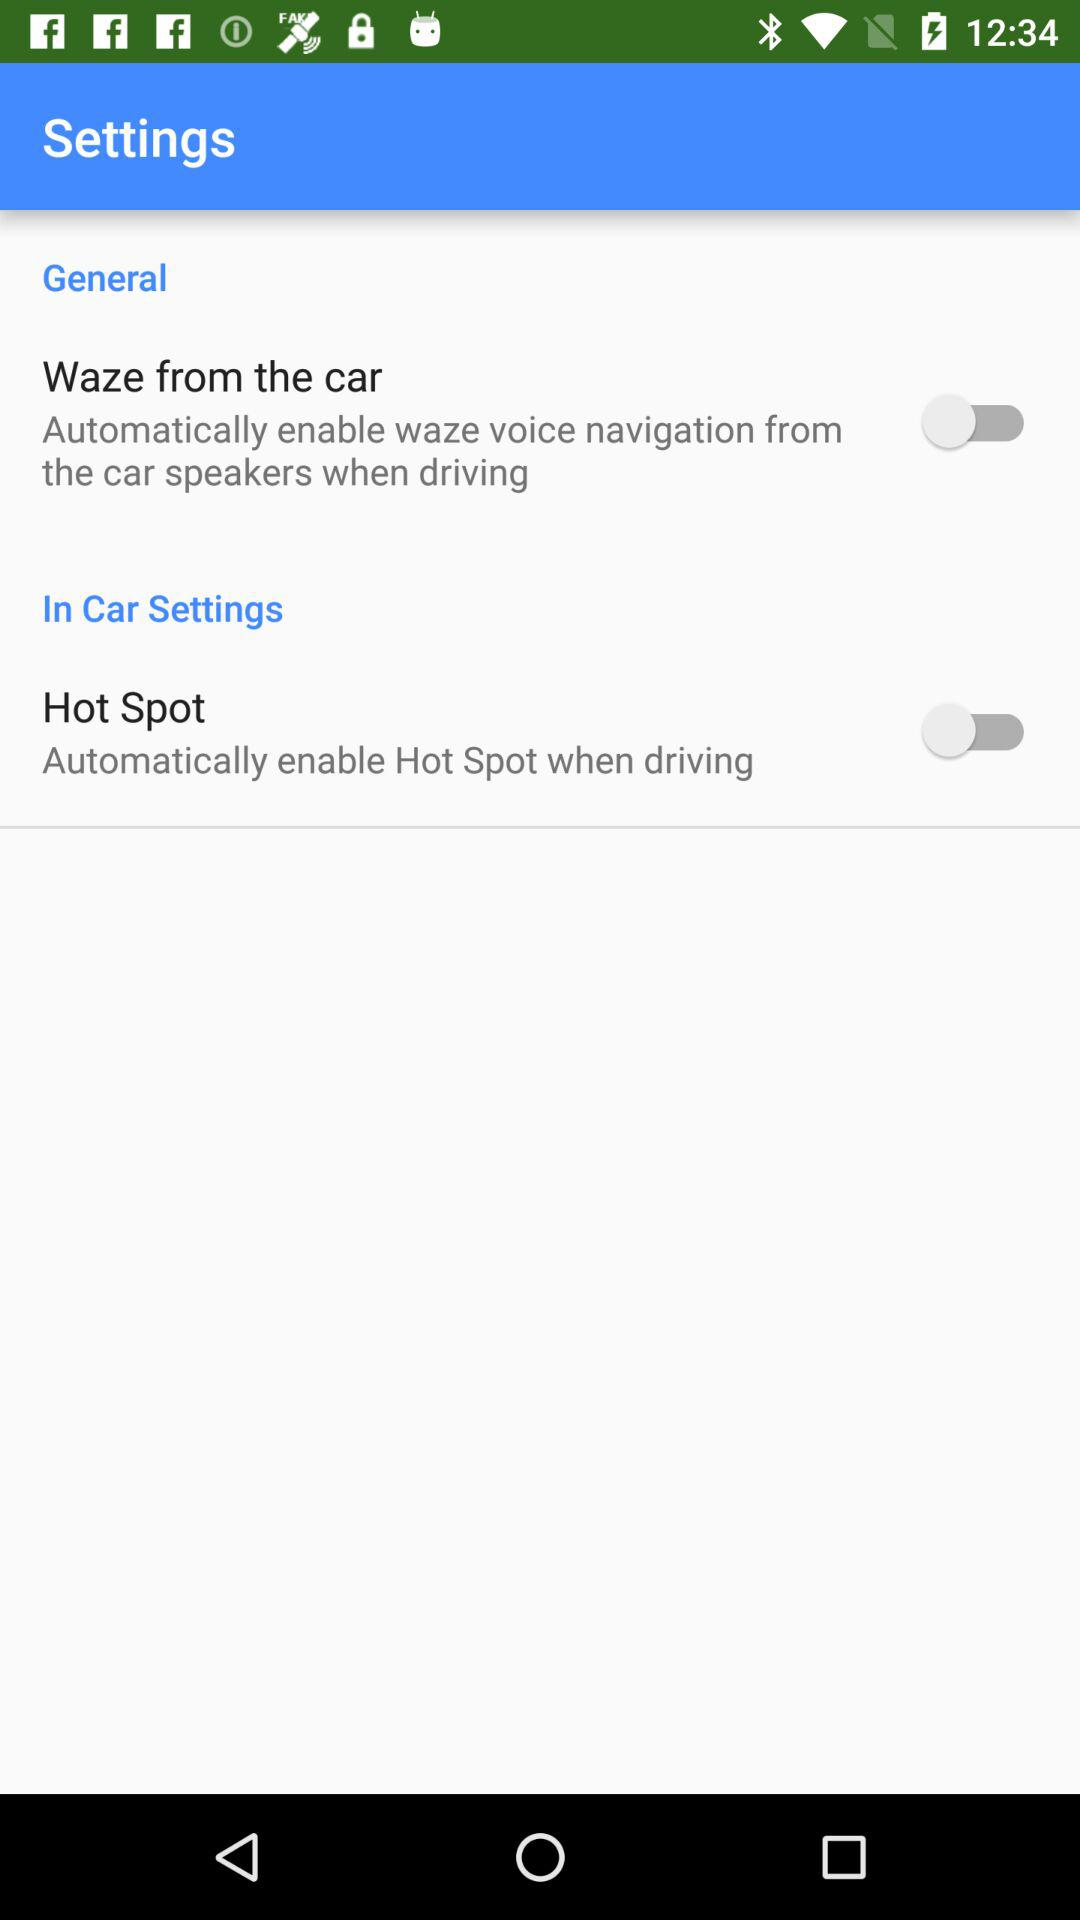What is the status of the "Waze from the car"? The status is "off". 